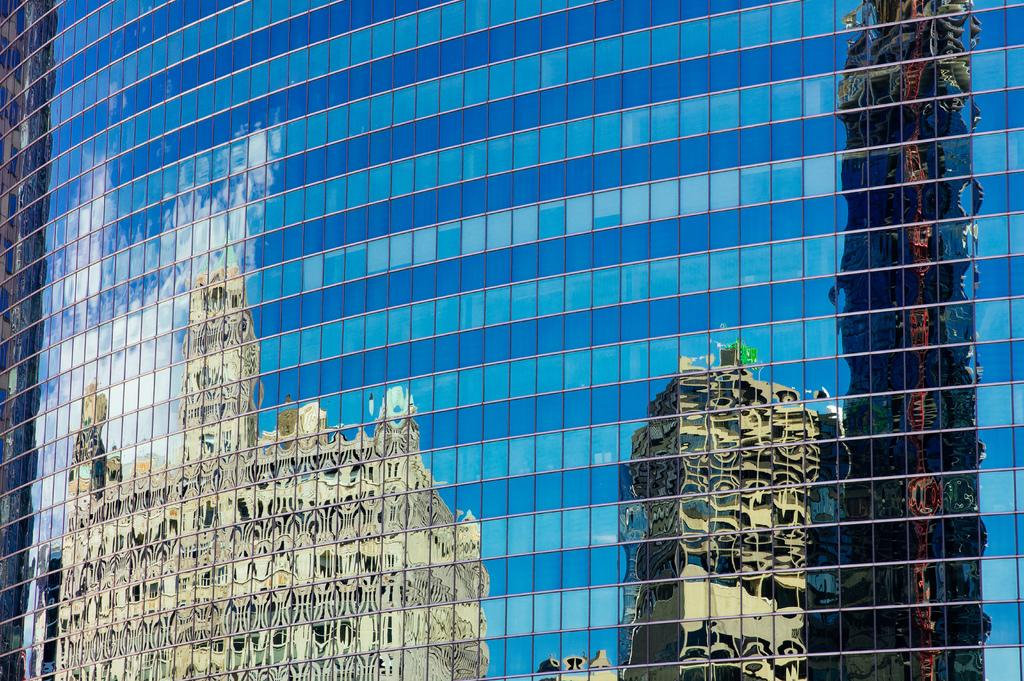What type of material is used for the windows in the image? The windows in the image are made of glass. What can be seen reflected on the glass windows? There is a reflection of buildings and the sky on the glass windows. What is visible in the sky in the image? Clouds are visible in the image. What type of news can be heard coming from the pan in the image? There is no pan present in the image, and therefore no news can be heard coming from it. 